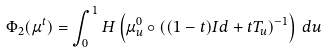<formula> <loc_0><loc_0><loc_500><loc_500>\Phi _ { 2 } ( \mu ^ { t } ) = \int _ { 0 } ^ { 1 } H \left ( \mu ^ { 0 } _ { u } \circ ( ( 1 - t ) I d + t T _ { u } ) ^ { - 1 } \right ) \, d u</formula> 